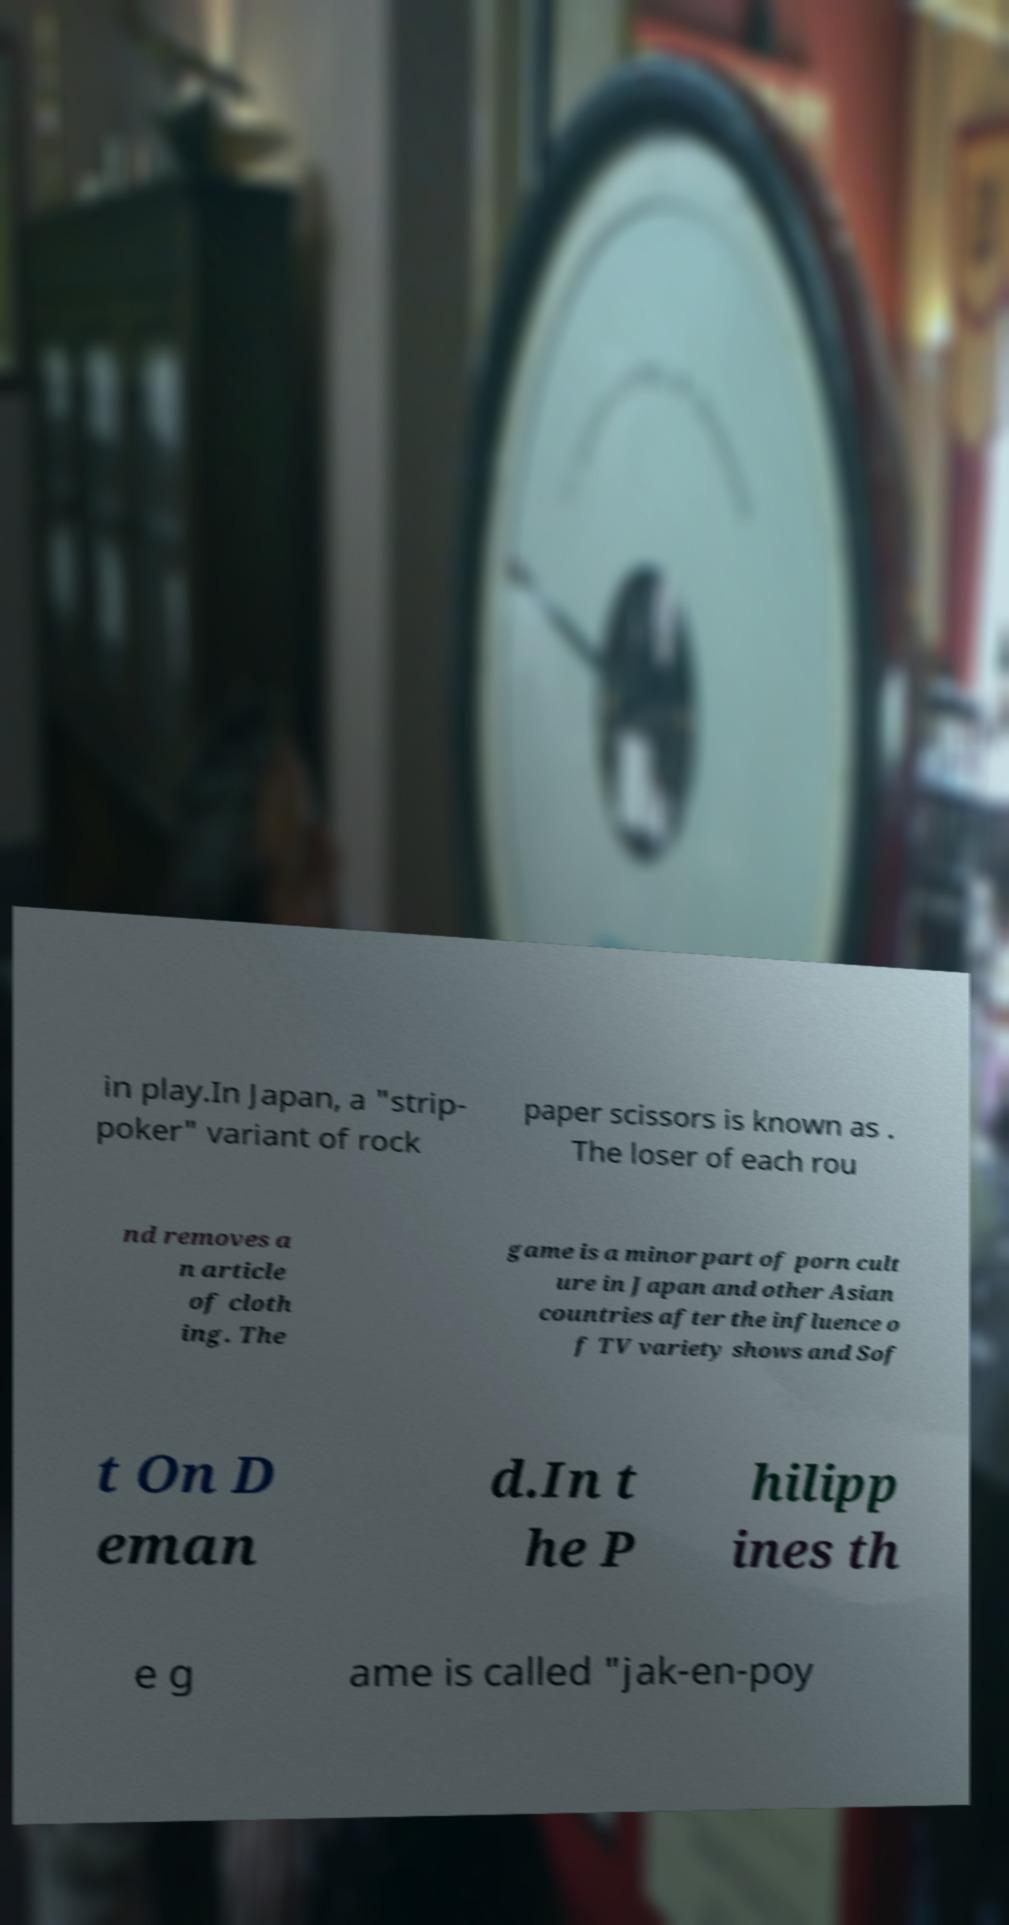I need the written content from this picture converted into text. Can you do that? in play.In Japan, a "strip- poker" variant of rock paper scissors is known as . The loser of each rou nd removes a n article of cloth ing. The game is a minor part of porn cult ure in Japan and other Asian countries after the influence o f TV variety shows and Sof t On D eman d.In t he P hilipp ines th e g ame is called "jak-en-poy 